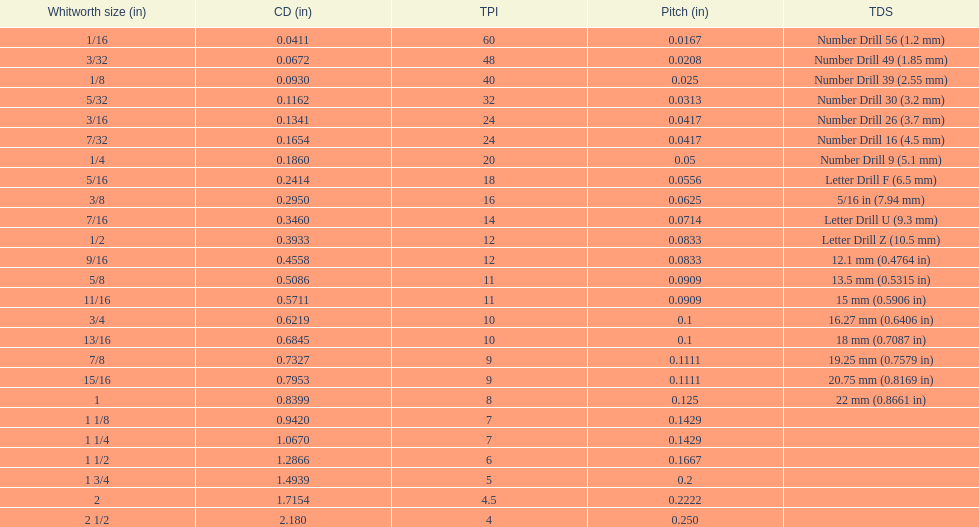What is the next whitworth size (in) below 1/8? 5/32. 